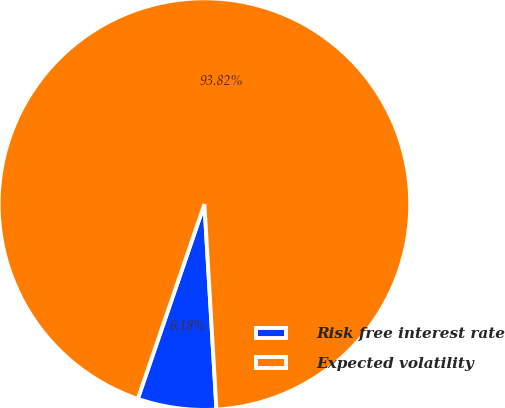Convert chart. <chart><loc_0><loc_0><loc_500><loc_500><pie_chart><fcel>Risk free interest rate<fcel>Expected volatility<nl><fcel>6.18%<fcel>93.82%<nl></chart> 